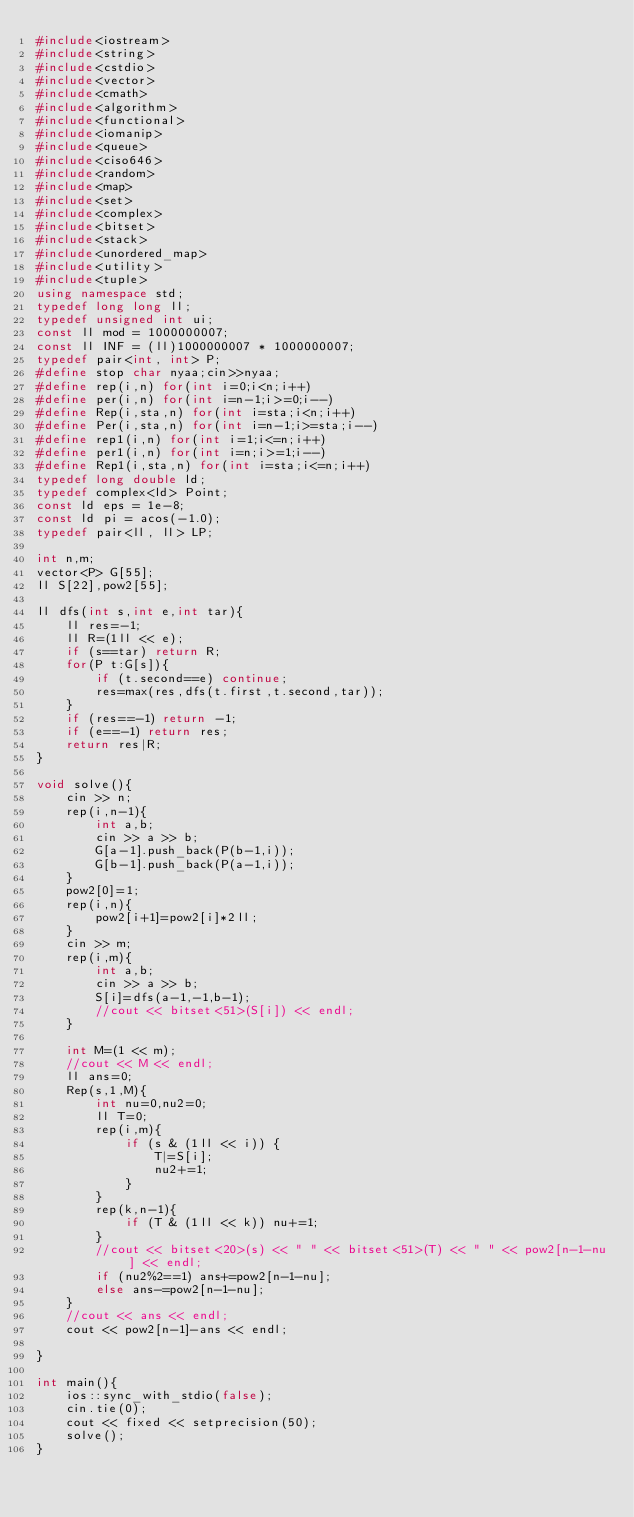<code> <loc_0><loc_0><loc_500><loc_500><_C++_>#include<iostream>
#include<string>
#include<cstdio>
#include<vector>
#include<cmath>
#include<algorithm>
#include<functional>
#include<iomanip>
#include<queue>
#include<ciso646>
#include<random>
#include<map>
#include<set>
#include<complex>
#include<bitset>
#include<stack>
#include<unordered_map>
#include<utility>
#include<tuple>
using namespace std;
typedef long long ll;
typedef unsigned int ui;
const ll mod = 1000000007;
const ll INF = (ll)1000000007 * 1000000007;
typedef pair<int, int> P;
#define stop char nyaa;cin>>nyaa;
#define rep(i,n) for(int i=0;i<n;i++)
#define per(i,n) for(int i=n-1;i>=0;i--)
#define Rep(i,sta,n) for(int i=sta;i<n;i++)
#define Per(i,sta,n) for(int i=n-1;i>=sta;i--)
#define rep1(i,n) for(int i=1;i<=n;i++)
#define per1(i,n) for(int i=n;i>=1;i--)
#define Rep1(i,sta,n) for(int i=sta;i<=n;i++)
typedef long double ld;
typedef complex<ld> Point;
const ld eps = 1e-8;
const ld pi = acos(-1.0);
typedef pair<ll, ll> LP;

int n,m;
vector<P> G[55];
ll S[22],pow2[55];

ll dfs(int s,int e,int tar){
    ll res=-1;
    ll R=(1ll << e);
    if (s==tar) return R;
    for(P t:G[s]){
        if (t.second==e) continue;
        res=max(res,dfs(t.first,t.second,tar));
    }
    if (res==-1) return -1;
    if (e==-1) return res;
    return res|R;
}

void solve(){
    cin >> n;
    rep(i,n-1){
        int a,b;
        cin >> a >> b;
        G[a-1].push_back(P(b-1,i));
        G[b-1].push_back(P(a-1,i));
    }
    pow2[0]=1;
    rep(i,n){
        pow2[i+1]=pow2[i]*2ll;
    }
    cin >> m;
    rep(i,m){
        int a,b;
        cin >> a >> b;
        S[i]=dfs(a-1,-1,b-1);
        //cout << bitset<51>(S[i]) << endl;
    }
    
    int M=(1 << m);
    //cout << M << endl;
    ll ans=0;
    Rep(s,1,M){
        int nu=0,nu2=0;
        ll T=0;
        rep(i,m){
            if (s & (1ll << i)) {
                T|=S[i];
                nu2+=1;
            }
        }
        rep(k,n-1){
            if (T & (1ll << k)) nu+=1;
        }
        //cout << bitset<20>(s) << " " << bitset<51>(T) << " " << pow2[n-1-nu] << endl;
        if (nu2%2==1) ans+=pow2[n-1-nu];
        else ans-=pow2[n-1-nu];
    }
    //cout << ans << endl;
    cout << pow2[n-1]-ans << endl;

}

int main(){
    ios::sync_with_stdio(false);
    cin.tie(0);
    cout << fixed << setprecision(50);
    solve();
}</code> 